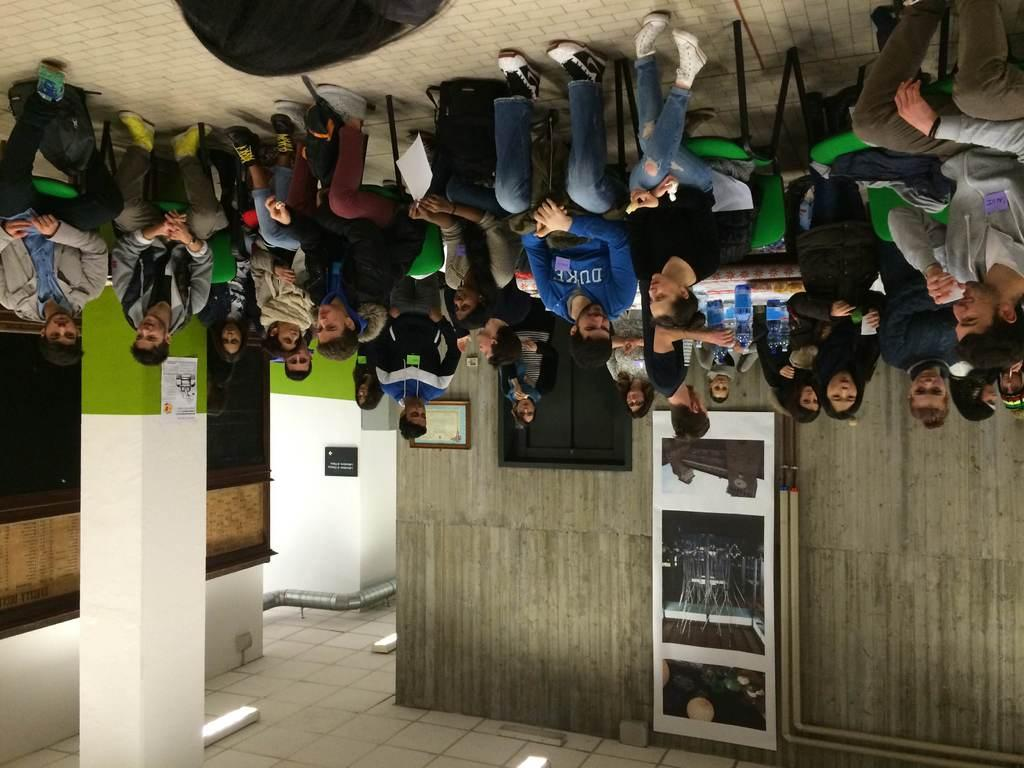What are the people in the image doing? People are seated on chairs in the image. What architectural feature can be seen in the image? There is a pillar in the image. What is hanging on the wall in the image? There is a photo frame on the wall in the image. What is present at the back of the image? A pipe is present at the back in the image. How many clovers are on the chairs in the image? There are no clovers present on the chairs in the image. Are there any bikes visible in the image? There are no bikes visible in the image. 